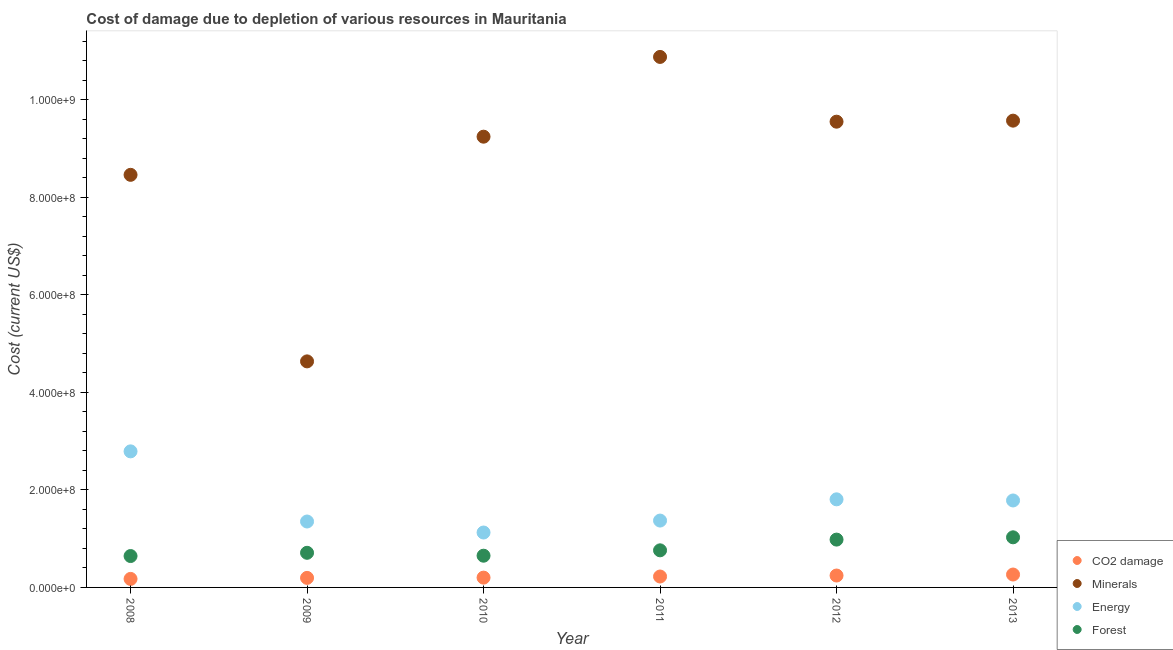How many different coloured dotlines are there?
Provide a succinct answer. 4. What is the cost of damage due to depletion of minerals in 2013?
Offer a terse response. 9.57e+08. Across all years, what is the maximum cost of damage due to depletion of energy?
Offer a terse response. 2.79e+08. Across all years, what is the minimum cost of damage due to depletion of coal?
Give a very brief answer. 1.75e+07. What is the total cost of damage due to depletion of coal in the graph?
Keep it short and to the point. 1.30e+08. What is the difference between the cost of damage due to depletion of minerals in 2009 and that in 2011?
Keep it short and to the point. -6.24e+08. What is the difference between the cost of damage due to depletion of minerals in 2012 and the cost of damage due to depletion of energy in 2009?
Provide a short and direct response. 8.20e+08. What is the average cost of damage due to depletion of energy per year?
Your answer should be compact. 1.71e+08. In the year 2008, what is the difference between the cost of damage due to depletion of energy and cost of damage due to depletion of forests?
Offer a terse response. 2.15e+08. What is the ratio of the cost of damage due to depletion of minerals in 2009 to that in 2011?
Your response must be concise. 0.43. Is the cost of damage due to depletion of minerals in 2010 less than that in 2011?
Keep it short and to the point. Yes. Is the difference between the cost of damage due to depletion of minerals in 2008 and 2010 greater than the difference between the cost of damage due to depletion of forests in 2008 and 2010?
Give a very brief answer. No. What is the difference between the highest and the second highest cost of damage due to depletion of forests?
Your answer should be compact. 4.69e+06. What is the difference between the highest and the lowest cost of damage due to depletion of energy?
Ensure brevity in your answer.  1.66e+08. Is it the case that in every year, the sum of the cost of damage due to depletion of forests and cost of damage due to depletion of coal is greater than the sum of cost of damage due to depletion of minerals and cost of damage due to depletion of energy?
Keep it short and to the point. No. Is it the case that in every year, the sum of the cost of damage due to depletion of coal and cost of damage due to depletion of minerals is greater than the cost of damage due to depletion of energy?
Your response must be concise. Yes. Does the cost of damage due to depletion of coal monotonically increase over the years?
Your response must be concise. Yes. Is the cost of damage due to depletion of coal strictly greater than the cost of damage due to depletion of minerals over the years?
Your response must be concise. No. Is the cost of damage due to depletion of energy strictly less than the cost of damage due to depletion of forests over the years?
Offer a terse response. No. How many dotlines are there?
Keep it short and to the point. 4. How many years are there in the graph?
Your answer should be very brief. 6. How many legend labels are there?
Make the answer very short. 4. How are the legend labels stacked?
Provide a short and direct response. Vertical. What is the title of the graph?
Ensure brevity in your answer.  Cost of damage due to depletion of various resources in Mauritania . What is the label or title of the X-axis?
Make the answer very short. Year. What is the label or title of the Y-axis?
Give a very brief answer. Cost (current US$). What is the Cost (current US$) of CO2 damage in 2008?
Make the answer very short. 1.75e+07. What is the Cost (current US$) of Minerals in 2008?
Keep it short and to the point. 8.46e+08. What is the Cost (current US$) in Energy in 2008?
Provide a short and direct response. 2.79e+08. What is the Cost (current US$) of Forest in 2008?
Offer a very short reply. 6.44e+07. What is the Cost (current US$) in CO2 damage in 2009?
Offer a very short reply. 1.96e+07. What is the Cost (current US$) in Minerals in 2009?
Ensure brevity in your answer.  4.64e+08. What is the Cost (current US$) in Energy in 2009?
Offer a terse response. 1.35e+08. What is the Cost (current US$) in Forest in 2009?
Provide a short and direct response. 7.10e+07. What is the Cost (current US$) in CO2 damage in 2010?
Make the answer very short. 2.01e+07. What is the Cost (current US$) of Minerals in 2010?
Your answer should be compact. 9.25e+08. What is the Cost (current US$) of Energy in 2010?
Offer a terse response. 1.13e+08. What is the Cost (current US$) in Forest in 2010?
Offer a terse response. 6.51e+07. What is the Cost (current US$) in CO2 damage in 2011?
Your answer should be very brief. 2.24e+07. What is the Cost (current US$) of Minerals in 2011?
Your response must be concise. 1.09e+09. What is the Cost (current US$) of Energy in 2011?
Make the answer very short. 1.37e+08. What is the Cost (current US$) of Forest in 2011?
Give a very brief answer. 7.61e+07. What is the Cost (current US$) in CO2 damage in 2012?
Your answer should be very brief. 2.44e+07. What is the Cost (current US$) of Minerals in 2012?
Your answer should be compact. 9.55e+08. What is the Cost (current US$) in Energy in 2012?
Give a very brief answer. 1.81e+08. What is the Cost (current US$) in Forest in 2012?
Your answer should be compact. 9.81e+07. What is the Cost (current US$) in CO2 damage in 2013?
Provide a succinct answer. 2.65e+07. What is the Cost (current US$) in Minerals in 2013?
Your answer should be compact. 9.57e+08. What is the Cost (current US$) of Energy in 2013?
Keep it short and to the point. 1.78e+08. What is the Cost (current US$) of Forest in 2013?
Your response must be concise. 1.03e+08. Across all years, what is the maximum Cost (current US$) in CO2 damage?
Offer a very short reply. 2.65e+07. Across all years, what is the maximum Cost (current US$) of Minerals?
Make the answer very short. 1.09e+09. Across all years, what is the maximum Cost (current US$) of Energy?
Your answer should be compact. 2.79e+08. Across all years, what is the maximum Cost (current US$) of Forest?
Offer a terse response. 1.03e+08. Across all years, what is the minimum Cost (current US$) of CO2 damage?
Provide a short and direct response. 1.75e+07. Across all years, what is the minimum Cost (current US$) in Minerals?
Your answer should be compact. 4.64e+08. Across all years, what is the minimum Cost (current US$) in Energy?
Give a very brief answer. 1.13e+08. Across all years, what is the minimum Cost (current US$) of Forest?
Keep it short and to the point. 6.44e+07. What is the total Cost (current US$) of CO2 damage in the graph?
Ensure brevity in your answer.  1.30e+08. What is the total Cost (current US$) in Minerals in the graph?
Your answer should be very brief. 5.24e+09. What is the total Cost (current US$) in Energy in the graph?
Make the answer very short. 1.02e+09. What is the total Cost (current US$) in Forest in the graph?
Your answer should be compact. 4.77e+08. What is the difference between the Cost (current US$) in CO2 damage in 2008 and that in 2009?
Offer a terse response. -2.10e+06. What is the difference between the Cost (current US$) in Minerals in 2008 and that in 2009?
Your response must be concise. 3.83e+08. What is the difference between the Cost (current US$) in Energy in 2008 and that in 2009?
Provide a short and direct response. 1.44e+08. What is the difference between the Cost (current US$) in Forest in 2008 and that in 2009?
Provide a short and direct response. -6.65e+06. What is the difference between the Cost (current US$) in CO2 damage in 2008 and that in 2010?
Your answer should be compact. -2.62e+06. What is the difference between the Cost (current US$) of Minerals in 2008 and that in 2010?
Make the answer very short. -7.82e+07. What is the difference between the Cost (current US$) in Energy in 2008 and that in 2010?
Provide a short and direct response. 1.66e+08. What is the difference between the Cost (current US$) in Forest in 2008 and that in 2010?
Keep it short and to the point. -6.86e+05. What is the difference between the Cost (current US$) of CO2 damage in 2008 and that in 2011?
Your response must be concise. -4.92e+06. What is the difference between the Cost (current US$) in Minerals in 2008 and that in 2011?
Your response must be concise. -2.42e+08. What is the difference between the Cost (current US$) of Energy in 2008 and that in 2011?
Make the answer very short. 1.42e+08. What is the difference between the Cost (current US$) in Forest in 2008 and that in 2011?
Provide a succinct answer. -1.17e+07. What is the difference between the Cost (current US$) in CO2 damage in 2008 and that in 2012?
Give a very brief answer. -6.94e+06. What is the difference between the Cost (current US$) in Minerals in 2008 and that in 2012?
Give a very brief answer. -1.09e+08. What is the difference between the Cost (current US$) of Energy in 2008 and that in 2012?
Make the answer very short. 9.84e+07. What is the difference between the Cost (current US$) of Forest in 2008 and that in 2012?
Your answer should be very brief. -3.37e+07. What is the difference between the Cost (current US$) of CO2 damage in 2008 and that in 2013?
Keep it short and to the point. -8.98e+06. What is the difference between the Cost (current US$) of Minerals in 2008 and that in 2013?
Provide a succinct answer. -1.11e+08. What is the difference between the Cost (current US$) of Energy in 2008 and that in 2013?
Offer a very short reply. 1.01e+08. What is the difference between the Cost (current US$) of Forest in 2008 and that in 2013?
Your answer should be compact. -3.84e+07. What is the difference between the Cost (current US$) in CO2 damage in 2009 and that in 2010?
Your answer should be compact. -5.16e+05. What is the difference between the Cost (current US$) of Minerals in 2009 and that in 2010?
Your response must be concise. -4.61e+08. What is the difference between the Cost (current US$) in Energy in 2009 and that in 2010?
Offer a very short reply. 2.26e+07. What is the difference between the Cost (current US$) of Forest in 2009 and that in 2010?
Give a very brief answer. 5.96e+06. What is the difference between the Cost (current US$) of CO2 damage in 2009 and that in 2011?
Provide a short and direct response. -2.82e+06. What is the difference between the Cost (current US$) of Minerals in 2009 and that in 2011?
Make the answer very short. -6.24e+08. What is the difference between the Cost (current US$) of Energy in 2009 and that in 2011?
Offer a very short reply. -1.92e+06. What is the difference between the Cost (current US$) in Forest in 2009 and that in 2011?
Ensure brevity in your answer.  -5.06e+06. What is the difference between the Cost (current US$) in CO2 damage in 2009 and that in 2012?
Offer a terse response. -4.83e+06. What is the difference between the Cost (current US$) of Minerals in 2009 and that in 2012?
Your response must be concise. -4.92e+08. What is the difference between the Cost (current US$) in Energy in 2009 and that in 2012?
Your answer should be compact. -4.55e+07. What is the difference between the Cost (current US$) in Forest in 2009 and that in 2012?
Keep it short and to the point. -2.71e+07. What is the difference between the Cost (current US$) in CO2 damage in 2009 and that in 2013?
Provide a short and direct response. -6.88e+06. What is the difference between the Cost (current US$) of Minerals in 2009 and that in 2013?
Your answer should be compact. -4.94e+08. What is the difference between the Cost (current US$) of Energy in 2009 and that in 2013?
Your answer should be very brief. -4.32e+07. What is the difference between the Cost (current US$) of Forest in 2009 and that in 2013?
Make the answer very short. -3.18e+07. What is the difference between the Cost (current US$) in CO2 damage in 2010 and that in 2011?
Offer a terse response. -2.30e+06. What is the difference between the Cost (current US$) in Minerals in 2010 and that in 2011?
Provide a succinct answer. -1.64e+08. What is the difference between the Cost (current US$) of Energy in 2010 and that in 2011?
Offer a terse response. -2.45e+07. What is the difference between the Cost (current US$) of Forest in 2010 and that in 2011?
Ensure brevity in your answer.  -1.10e+07. What is the difference between the Cost (current US$) of CO2 damage in 2010 and that in 2012?
Make the answer very short. -4.32e+06. What is the difference between the Cost (current US$) of Minerals in 2010 and that in 2012?
Your answer should be compact. -3.08e+07. What is the difference between the Cost (current US$) in Energy in 2010 and that in 2012?
Provide a short and direct response. -6.81e+07. What is the difference between the Cost (current US$) of Forest in 2010 and that in 2012?
Your answer should be compact. -3.30e+07. What is the difference between the Cost (current US$) of CO2 damage in 2010 and that in 2013?
Provide a succinct answer. -6.36e+06. What is the difference between the Cost (current US$) in Minerals in 2010 and that in 2013?
Keep it short and to the point. -3.29e+07. What is the difference between the Cost (current US$) in Energy in 2010 and that in 2013?
Your answer should be very brief. -6.57e+07. What is the difference between the Cost (current US$) in Forest in 2010 and that in 2013?
Your answer should be very brief. -3.77e+07. What is the difference between the Cost (current US$) in CO2 damage in 2011 and that in 2012?
Your response must be concise. -2.02e+06. What is the difference between the Cost (current US$) in Minerals in 2011 and that in 2012?
Keep it short and to the point. 1.33e+08. What is the difference between the Cost (current US$) of Energy in 2011 and that in 2012?
Make the answer very short. -4.36e+07. What is the difference between the Cost (current US$) in Forest in 2011 and that in 2012?
Provide a succinct answer. -2.20e+07. What is the difference between the Cost (current US$) in CO2 damage in 2011 and that in 2013?
Your answer should be compact. -4.06e+06. What is the difference between the Cost (current US$) in Minerals in 2011 and that in 2013?
Provide a short and direct response. 1.31e+08. What is the difference between the Cost (current US$) in Energy in 2011 and that in 2013?
Offer a terse response. -4.12e+07. What is the difference between the Cost (current US$) of Forest in 2011 and that in 2013?
Provide a short and direct response. -2.67e+07. What is the difference between the Cost (current US$) of CO2 damage in 2012 and that in 2013?
Provide a succinct answer. -2.04e+06. What is the difference between the Cost (current US$) in Minerals in 2012 and that in 2013?
Keep it short and to the point. -2.13e+06. What is the difference between the Cost (current US$) in Energy in 2012 and that in 2013?
Your response must be concise. 2.34e+06. What is the difference between the Cost (current US$) in Forest in 2012 and that in 2013?
Your answer should be compact. -4.69e+06. What is the difference between the Cost (current US$) in CO2 damage in 2008 and the Cost (current US$) in Minerals in 2009?
Give a very brief answer. -4.46e+08. What is the difference between the Cost (current US$) in CO2 damage in 2008 and the Cost (current US$) in Energy in 2009?
Your answer should be very brief. -1.18e+08. What is the difference between the Cost (current US$) of CO2 damage in 2008 and the Cost (current US$) of Forest in 2009?
Give a very brief answer. -5.36e+07. What is the difference between the Cost (current US$) in Minerals in 2008 and the Cost (current US$) in Energy in 2009?
Your answer should be compact. 7.11e+08. What is the difference between the Cost (current US$) of Minerals in 2008 and the Cost (current US$) of Forest in 2009?
Make the answer very short. 7.75e+08. What is the difference between the Cost (current US$) of Energy in 2008 and the Cost (current US$) of Forest in 2009?
Offer a terse response. 2.08e+08. What is the difference between the Cost (current US$) of CO2 damage in 2008 and the Cost (current US$) of Minerals in 2010?
Make the answer very short. -9.07e+08. What is the difference between the Cost (current US$) in CO2 damage in 2008 and the Cost (current US$) in Energy in 2010?
Your answer should be very brief. -9.52e+07. What is the difference between the Cost (current US$) of CO2 damage in 2008 and the Cost (current US$) of Forest in 2010?
Your answer should be very brief. -4.76e+07. What is the difference between the Cost (current US$) of Minerals in 2008 and the Cost (current US$) of Energy in 2010?
Your answer should be very brief. 7.34e+08. What is the difference between the Cost (current US$) in Minerals in 2008 and the Cost (current US$) in Forest in 2010?
Give a very brief answer. 7.81e+08. What is the difference between the Cost (current US$) in Energy in 2008 and the Cost (current US$) in Forest in 2010?
Make the answer very short. 2.14e+08. What is the difference between the Cost (current US$) of CO2 damage in 2008 and the Cost (current US$) of Minerals in 2011?
Offer a terse response. -1.07e+09. What is the difference between the Cost (current US$) of CO2 damage in 2008 and the Cost (current US$) of Energy in 2011?
Keep it short and to the point. -1.20e+08. What is the difference between the Cost (current US$) in CO2 damage in 2008 and the Cost (current US$) in Forest in 2011?
Provide a succinct answer. -5.86e+07. What is the difference between the Cost (current US$) in Minerals in 2008 and the Cost (current US$) in Energy in 2011?
Give a very brief answer. 7.09e+08. What is the difference between the Cost (current US$) in Minerals in 2008 and the Cost (current US$) in Forest in 2011?
Provide a short and direct response. 7.70e+08. What is the difference between the Cost (current US$) in Energy in 2008 and the Cost (current US$) in Forest in 2011?
Offer a very short reply. 2.03e+08. What is the difference between the Cost (current US$) in CO2 damage in 2008 and the Cost (current US$) in Minerals in 2012?
Your answer should be compact. -9.38e+08. What is the difference between the Cost (current US$) in CO2 damage in 2008 and the Cost (current US$) in Energy in 2012?
Your answer should be very brief. -1.63e+08. What is the difference between the Cost (current US$) in CO2 damage in 2008 and the Cost (current US$) in Forest in 2012?
Your answer should be compact. -8.06e+07. What is the difference between the Cost (current US$) in Minerals in 2008 and the Cost (current US$) in Energy in 2012?
Your answer should be compact. 6.66e+08. What is the difference between the Cost (current US$) in Minerals in 2008 and the Cost (current US$) in Forest in 2012?
Provide a short and direct response. 7.48e+08. What is the difference between the Cost (current US$) in Energy in 2008 and the Cost (current US$) in Forest in 2012?
Make the answer very short. 1.81e+08. What is the difference between the Cost (current US$) in CO2 damage in 2008 and the Cost (current US$) in Minerals in 2013?
Provide a succinct answer. -9.40e+08. What is the difference between the Cost (current US$) of CO2 damage in 2008 and the Cost (current US$) of Energy in 2013?
Offer a terse response. -1.61e+08. What is the difference between the Cost (current US$) of CO2 damage in 2008 and the Cost (current US$) of Forest in 2013?
Give a very brief answer. -8.53e+07. What is the difference between the Cost (current US$) of Minerals in 2008 and the Cost (current US$) of Energy in 2013?
Ensure brevity in your answer.  6.68e+08. What is the difference between the Cost (current US$) in Minerals in 2008 and the Cost (current US$) in Forest in 2013?
Your response must be concise. 7.44e+08. What is the difference between the Cost (current US$) in Energy in 2008 and the Cost (current US$) in Forest in 2013?
Ensure brevity in your answer.  1.76e+08. What is the difference between the Cost (current US$) of CO2 damage in 2009 and the Cost (current US$) of Minerals in 2010?
Offer a very short reply. -9.05e+08. What is the difference between the Cost (current US$) of CO2 damage in 2009 and the Cost (current US$) of Energy in 2010?
Your response must be concise. -9.31e+07. What is the difference between the Cost (current US$) in CO2 damage in 2009 and the Cost (current US$) in Forest in 2010?
Offer a very short reply. -4.55e+07. What is the difference between the Cost (current US$) in Minerals in 2009 and the Cost (current US$) in Energy in 2010?
Offer a very short reply. 3.51e+08. What is the difference between the Cost (current US$) of Minerals in 2009 and the Cost (current US$) of Forest in 2010?
Your answer should be very brief. 3.99e+08. What is the difference between the Cost (current US$) of Energy in 2009 and the Cost (current US$) of Forest in 2010?
Your response must be concise. 7.01e+07. What is the difference between the Cost (current US$) of CO2 damage in 2009 and the Cost (current US$) of Minerals in 2011?
Provide a short and direct response. -1.07e+09. What is the difference between the Cost (current US$) in CO2 damage in 2009 and the Cost (current US$) in Energy in 2011?
Provide a short and direct response. -1.18e+08. What is the difference between the Cost (current US$) in CO2 damage in 2009 and the Cost (current US$) in Forest in 2011?
Make the answer very short. -5.65e+07. What is the difference between the Cost (current US$) in Minerals in 2009 and the Cost (current US$) in Energy in 2011?
Make the answer very short. 3.27e+08. What is the difference between the Cost (current US$) in Minerals in 2009 and the Cost (current US$) in Forest in 2011?
Your response must be concise. 3.88e+08. What is the difference between the Cost (current US$) in Energy in 2009 and the Cost (current US$) in Forest in 2011?
Make the answer very short. 5.91e+07. What is the difference between the Cost (current US$) in CO2 damage in 2009 and the Cost (current US$) in Minerals in 2012?
Ensure brevity in your answer.  -9.36e+08. What is the difference between the Cost (current US$) of CO2 damage in 2009 and the Cost (current US$) of Energy in 2012?
Ensure brevity in your answer.  -1.61e+08. What is the difference between the Cost (current US$) in CO2 damage in 2009 and the Cost (current US$) in Forest in 2012?
Offer a terse response. -7.85e+07. What is the difference between the Cost (current US$) in Minerals in 2009 and the Cost (current US$) in Energy in 2012?
Provide a succinct answer. 2.83e+08. What is the difference between the Cost (current US$) of Minerals in 2009 and the Cost (current US$) of Forest in 2012?
Your response must be concise. 3.66e+08. What is the difference between the Cost (current US$) of Energy in 2009 and the Cost (current US$) of Forest in 2012?
Provide a succinct answer. 3.71e+07. What is the difference between the Cost (current US$) in CO2 damage in 2009 and the Cost (current US$) in Minerals in 2013?
Your answer should be very brief. -9.38e+08. What is the difference between the Cost (current US$) of CO2 damage in 2009 and the Cost (current US$) of Energy in 2013?
Offer a very short reply. -1.59e+08. What is the difference between the Cost (current US$) of CO2 damage in 2009 and the Cost (current US$) of Forest in 2013?
Your answer should be very brief. -8.32e+07. What is the difference between the Cost (current US$) of Minerals in 2009 and the Cost (current US$) of Energy in 2013?
Offer a terse response. 2.85e+08. What is the difference between the Cost (current US$) of Minerals in 2009 and the Cost (current US$) of Forest in 2013?
Make the answer very short. 3.61e+08. What is the difference between the Cost (current US$) of Energy in 2009 and the Cost (current US$) of Forest in 2013?
Provide a succinct answer. 3.24e+07. What is the difference between the Cost (current US$) in CO2 damage in 2010 and the Cost (current US$) in Minerals in 2011?
Your response must be concise. -1.07e+09. What is the difference between the Cost (current US$) of CO2 damage in 2010 and the Cost (current US$) of Energy in 2011?
Make the answer very short. -1.17e+08. What is the difference between the Cost (current US$) in CO2 damage in 2010 and the Cost (current US$) in Forest in 2011?
Ensure brevity in your answer.  -5.60e+07. What is the difference between the Cost (current US$) in Minerals in 2010 and the Cost (current US$) in Energy in 2011?
Ensure brevity in your answer.  7.87e+08. What is the difference between the Cost (current US$) in Minerals in 2010 and the Cost (current US$) in Forest in 2011?
Provide a short and direct response. 8.48e+08. What is the difference between the Cost (current US$) of Energy in 2010 and the Cost (current US$) of Forest in 2011?
Ensure brevity in your answer.  3.65e+07. What is the difference between the Cost (current US$) in CO2 damage in 2010 and the Cost (current US$) in Minerals in 2012?
Give a very brief answer. -9.35e+08. What is the difference between the Cost (current US$) in CO2 damage in 2010 and the Cost (current US$) in Energy in 2012?
Offer a terse response. -1.61e+08. What is the difference between the Cost (current US$) of CO2 damage in 2010 and the Cost (current US$) of Forest in 2012?
Your answer should be very brief. -7.80e+07. What is the difference between the Cost (current US$) in Minerals in 2010 and the Cost (current US$) in Energy in 2012?
Your answer should be compact. 7.44e+08. What is the difference between the Cost (current US$) of Minerals in 2010 and the Cost (current US$) of Forest in 2012?
Provide a succinct answer. 8.26e+08. What is the difference between the Cost (current US$) in Energy in 2010 and the Cost (current US$) in Forest in 2012?
Your answer should be compact. 1.45e+07. What is the difference between the Cost (current US$) of CO2 damage in 2010 and the Cost (current US$) of Minerals in 2013?
Your answer should be very brief. -9.37e+08. What is the difference between the Cost (current US$) of CO2 damage in 2010 and the Cost (current US$) of Energy in 2013?
Provide a succinct answer. -1.58e+08. What is the difference between the Cost (current US$) of CO2 damage in 2010 and the Cost (current US$) of Forest in 2013?
Provide a succinct answer. -8.27e+07. What is the difference between the Cost (current US$) in Minerals in 2010 and the Cost (current US$) in Energy in 2013?
Your answer should be compact. 7.46e+08. What is the difference between the Cost (current US$) in Minerals in 2010 and the Cost (current US$) in Forest in 2013?
Offer a terse response. 8.22e+08. What is the difference between the Cost (current US$) of Energy in 2010 and the Cost (current US$) of Forest in 2013?
Offer a terse response. 9.83e+06. What is the difference between the Cost (current US$) in CO2 damage in 2011 and the Cost (current US$) in Minerals in 2012?
Your answer should be very brief. -9.33e+08. What is the difference between the Cost (current US$) in CO2 damage in 2011 and the Cost (current US$) in Energy in 2012?
Offer a terse response. -1.58e+08. What is the difference between the Cost (current US$) of CO2 damage in 2011 and the Cost (current US$) of Forest in 2012?
Your response must be concise. -7.57e+07. What is the difference between the Cost (current US$) of Minerals in 2011 and the Cost (current US$) of Energy in 2012?
Give a very brief answer. 9.07e+08. What is the difference between the Cost (current US$) in Minerals in 2011 and the Cost (current US$) in Forest in 2012?
Your answer should be compact. 9.90e+08. What is the difference between the Cost (current US$) of Energy in 2011 and the Cost (current US$) of Forest in 2012?
Provide a short and direct response. 3.90e+07. What is the difference between the Cost (current US$) in CO2 damage in 2011 and the Cost (current US$) in Minerals in 2013?
Your response must be concise. -9.35e+08. What is the difference between the Cost (current US$) in CO2 damage in 2011 and the Cost (current US$) in Energy in 2013?
Your answer should be compact. -1.56e+08. What is the difference between the Cost (current US$) in CO2 damage in 2011 and the Cost (current US$) in Forest in 2013?
Give a very brief answer. -8.04e+07. What is the difference between the Cost (current US$) of Minerals in 2011 and the Cost (current US$) of Energy in 2013?
Give a very brief answer. 9.10e+08. What is the difference between the Cost (current US$) in Minerals in 2011 and the Cost (current US$) in Forest in 2013?
Make the answer very short. 9.85e+08. What is the difference between the Cost (current US$) of Energy in 2011 and the Cost (current US$) of Forest in 2013?
Your answer should be compact. 3.43e+07. What is the difference between the Cost (current US$) of CO2 damage in 2012 and the Cost (current US$) of Minerals in 2013?
Your answer should be very brief. -9.33e+08. What is the difference between the Cost (current US$) in CO2 damage in 2012 and the Cost (current US$) in Energy in 2013?
Offer a terse response. -1.54e+08. What is the difference between the Cost (current US$) in CO2 damage in 2012 and the Cost (current US$) in Forest in 2013?
Provide a succinct answer. -7.84e+07. What is the difference between the Cost (current US$) in Minerals in 2012 and the Cost (current US$) in Energy in 2013?
Ensure brevity in your answer.  7.77e+08. What is the difference between the Cost (current US$) in Minerals in 2012 and the Cost (current US$) in Forest in 2013?
Your answer should be very brief. 8.53e+08. What is the difference between the Cost (current US$) of Energy in 2012 and the Cost (current US$) of Forest in 2013?
Keep it short and to the point. 7.79e+07. What is the average Cost (current US$) of CO2 damage per year?
Keep it short and to the point. 2.17e+07. What is the average Cost (current US$) of Minerals per year?
Keep it short and to the point. 8.73e+08. What is the average Cost (current US$) in Energy per year?
Give a very brief answer. 1.71e+08. What is the average Cost (current US$) in Forest per year?
Offer a terse response. 7.96e+07. In the year 2008, what is the difference between the Cost (current US$) in CO2 damage and Cost (current US$) in Minerals?
Keep it short and to the point. -8.29e+08. In the year 2008, what is the difference between the Cost (current US$) in CO2 damage and Cost (current US$) in Energy?
Your response must be concise. -2.62e+08. In the year 2008, what is the difference between the Cost (current US$) of CO2 damage and Cost (current US$) of Forest?
Make the answer very short. -4.69e+07. In the year 2008, what is the difference between the Cost (current US$) in Minerals and Cost (current US$) in Energy?
Give a very brief answer. 5.67e+08. In the year 2008, what is the difference between the Cost (current US$) of Minerals and Cost (current US$) of Forest?
Ensure brevity in your answer.  7.82e+08. In the year 2008, what is the difference between the Cost (current US$) of Energy and Cost (current US$) of Forest?
Your answer should be compact. 2.15e+08. In the year 2009, what is the difference between the Cost (current US$) of CO2 damage and Cost (current US$) of Minerals?
Your answer should be very brief. -4.44e+08. In the year 2009, what is the difference between the Cost (current US$) in CO2 damage and Cost (current US$) in Energy?
Your response must be concise. -1.16e+08. In the year 2009, what is the difference between the Cost (current US$) in CO2 damage and Cost (current US$) in Forest?
Give a very brief answer. -5.15e+07. In the year 2009, what is the difference between the Cost (current US$) of Minerals and Cost (current US$) of Energy?
Make the answer very short. 3.28e+08. In the year 2009, what is the difference between the Cost (current US$) of Minerals and Cost (current US$) of Forest?
Provide a short and direct response. 3.93e+08. In the year 2009, what is the difference between the Cost (current US$) of Energy and Cost (current US$) of Forest?
Provide a succinct answer. 6.42e+07. In the year 2010, what is the difference between the Cost (current US$) of CO2 damage and Cost (current US$) of Minerals?
Ensure brevity in your answer.  -9.04e+08. In the year 2010, what is the difference between the Cost (current US$) in CO2 damage and Cost (current US$) in Energy?
Make the answer very short. -9.25e+07. In the year 2010, what is the difference between the Cost (current US$) of CO2 damage and Cost (current US$) of Forest?
Give a very brief answer. -4.50e+07. In the year 2010, what is the difference between the Cost (current US$) in Minerals and Cost (current US$) in Energy?
Your answer should be very brief. 8.12e+08. In the year 2010, what is the difference between the Cost (current US$) in Minerals and Cost (current US$) in Forest?
Your answer should be compact. 8.59e+08. In the year 2010, what is the difference between the Cost (current US$) of Energy and Cost (current US$) of Forest?
Keep it short and to the point. 4.76e+07. In the year 2011, what is the difference between the Cost (current US$) in CO2 damage and Cost (current US$) in Minerals?
Provide a succinct answer. -1.07e+09. In the year 2011, what is the difference between the Cost (current US$) in CO2 damage and Cost (current US$) in Energy?
Provide a short and direct response. -1.15e+08. In the year 2011, what is the difference between the Cost (current US$) in CO2 damage and Cost (current US$) in Forest?
Offer a terse response. -5.37e+07. In the year 2011, what is the difference between the Cost (current US$) in Minerals and Cost (current US$) in Energy?
Your answer should be very brief. 9.51e+08. In the year 2011, what is the difference between the Cost (current US$) of Minerals and Cost (current US$) of Forest?
Your response must be concise. 1.01e+09. In the year 2011, what is the difference between the Cost (current US$) in Energy and Cost (current US$) in Forest?
Your answer should be very brief. 6.10e+07. In the year 2012, what is the difference between the Cost (current US$) of CO2 damage and Cost (current US$) of Minerals?
Your answer should be very brief. -9.31e+08. In the year 2012, what is the difference between the Cost (current US$) of CO2 damage and Cost (current US$) of Energy?
Your answer should be very brief. -1.56e+08. In the year 2012, what is the difference between the Cost (current US$) in CO2 damage and Cost (current US$) in Forest?
Offer a terse response. -7.37e+07. In the year 2012, what is the difference between the Cost (current US$) of Minerals and Cost (current US$) of Energy?
Provide a short and direct response. 7.75e+08. In the year 2012, what is the difference between the Cost (current US$) in Minerals and Cost (current US$) in Forest?
Your response must be concise. 8.57e+08. In the year 2012, what is the difference between the Cost (current US$) in Energy and Cost (current US$) in Forest?
Your answer should be very brief. 8.26e+07. In the year 2013, what is the difference between the Cost (current US$) in CO2 damage and Cost (current US$) in Minerals?
Ensure brevity in your answer.  -9.31e+08. In the year 2013, what is the difference between the Cost (current US$) in CO2 damage and Cost (current US$) in Energy?
Offer a terse response. -1.52e+08. In the year 2013, what is the difference between the Cost (current US$) in CO2 damage and Cost (current US$) in Forest?
Your answer should be compact. -7.63e+07. In the year 2013, what is the difference between the Cost (current US$) of Minerals and Cost (current US$) of Energy?
Offer a very short reply. 7.79e+08. In the year 2013, what is the difference between the Cost (current US$) in Minerals and Cost (current US$) in Forest?
Ensure brevity in your answer.  8.55e+08. In the year 2013, what is the difference between the Cost (current US$) in Energy and Cost (current US$) in Forest?
Keep it short and to the point. 7.56e+07. What is the ratio of the Cost (current US$) in CO2 damage in 2008 to that in 2009?
Offer a very short reply. 0.89. What is the ratio of the Cost (current US$) of Minerals in 2008 to that in 2009?
Your answer should be very brief. 1.83. What is the ratio of the Cost (current US$) of Energy in 2008 to that in 2009?
Provide a short and direct response. 2.06. What is the ratio of the Cost (current US$) in Forest in 2008 to that in 2009?
Your answer should be compact. 0.91. What is the ratio of the Cost (current US$) in CO2 damage in 2008 to that in 2010?
Make the answer very short. 0.87. What is the ratio of the Cost (current US$) of Minerals in 2008 to that in 2010?
Offer a very short reply. 0.92. What is the ratio of the Cost (current US$) of Energy in 2008 to that in 2010?
Offer a terse response. 2.48. What is the ratio of the Cost (current US$) in CO2 damage in 2008 to that in 2011?
Offer a very short reply. 0.78. What is the ratio of the Cost (current US$) in Minerals in 2008 to that in 2011?
Make the answer very short. 0.78. What is the ratio of the Cost (current US$) of Energy in 2008 to that in 2011?
Provide a short and direct response. 2.04. What is the ratio of the Cost (current US$) in Forest in 2008 to that in 2011?
Offer a terse response. 0.85. What is the ratio of the Cost (current US$) in CO2 damage in 2008 to that in 2012?
Make the answer very short. 0.72. What is the ratio of the Cost (current US$) of Minerals in 2008 to that in 2012?
Keep it short and to the point. 0.89. What is the ratio of the Cost (current US$) in Energy in 2008 to that in 2012?
Keep it short and to the point. 1.54. What is the ratio of the Cost (current US$) of Forest in 2008 to that in 2012?
Ensure brevity in your answer.  0.66. What is the ratio of the Cost (current US$) of CO2 damage in 2008 to that in 2013?
Make the answer very short. 0.66. What is the ratio of the Cost (current US$) in Minerals in 2008 to that in 2013?
Provide a succinct answer. 0.88. What is the ratio of the Cost (current US$) of Energy in 2008 to that in 2013?
Give a very brief answer. 1.56. What is the ratio of the Cost (current US$) in Forest in 2008 to that in 2013?
Your answer should be very brief. 0.63. What is the ratio of the Cost (current US$) in CO2 damage in 2009 to that in 2010?
Your answer should be very brief. 0.97. What is the ratio of the Cost (current US$) of Minerals in 2009 to that in 2010?
Your answer should be compact. 0.5. What is the ratio of the Cost (current US$) in Energy in 2009 to that in 2010?
Keep it short and to the point. 1.2. What is the ratio of the Cost (current US$) of Forest in 2009 to that in 2010?
Offer a very short reply. 1.09. What is the ratio of the Cost (current US$) of CO2 damage in 2009 to that in 2011?
Your answer should be compact. 0.87. What is the ratio of the Cost (current US$) in Minerals in 2009 to that in 2011?
Provide a succinct answer. 0.43. What is the ratio of the Cost (current US$) in Forest in 2009 to that in 2011?
Your response must be concise. 0.93. What is the ratio of the Cost (current US$) of CO2 damage in 2009 to that in 2012?
Your answer should be compact. 0.8. What is the ratio of the Cost (current US$) of Minerals in 2009 to that in 2012?
Your answer should be compact. 0.49. What is the ratio of the Cost (current US$) of Energy in 2009 to that in 2012?
Your response must be concise. 0.75. What is the ratio of the Cost (current US$) of Forest in 2009 to that in 2012?
Ensure brevity in your answer.  0.72. What is the ratio of the Cost (current US$) in CO2 damage in 2009 to that in 2013?
Your answer should be compact. 0.74. What is the ratio of the Cost (current US$) of Minerals in 2009 to that in 2013?
Ensure brevity in your answer.  0.48. What is the ratio of the Cost (current US$) in Energy in 2009 to that in 2013?
Make the answer very short. 0.76. What is the ratio of the Cost (current US$) in Forest in 2009 to that in 2013?
Your answer should be compact. 0.69. What is the ratio of the Cost (current US$) of CO2 damage in 2010 to that in 2011?
Give a very brief answer. 0.9. What is the ratio of the Cost (current US$) in Minerals in 2010 to that in 2011?
Offer a very short reply. 0.85. What is the ratio of the Cost (current US$) of Energy in 2010 to that in 2011?
Your answer should be compact. 0.82. What is the ratio of the Cost (current US$) of Forest in 2010 to that in 2011?
Give a very brief answer. 0.86. What is the ratio of the Cost (current US$) in CO2 damage in 2010 to that in 2012?
Your answer should be very brief. 0.82. What is the ratio of the Cost (current US$) of Minerals in 2010 to that in 2012?
Your response must be concise. 0.97. What is the ratio of the Cost (current US$) of Energy in 2010 to that in 2012?
Provide a succinct answer. 0.62. What is the ratio of the Cost (current US$) in Forest in 2010 to that in 2012?
Offer a terse response. 0.66. What is the ratio of the Cost (current US$) of CO2 damage in 2010 to that in 2013?
Provide a succinct answer. 0.76. What is the ratio of the Cost (current US$) of Minerals in 2010 to that in 2013?
Your answer should be very brief. 0.97. What is the ratio of the Cost (current US$) in Energy in 2010 to that in 2013?
Offer a terse response. 0.63. What is the ratio of the Cost (current US$) in Forest in 2010 to that in 2013?
Ensure brevity in your answer.  0.63. What is the ratio of the Cost (current US$) in CO2 damage in 2011 to that in 2012?
Provide a succinct answer. 0.92. What is the ratio of the Cost (current US$) in Minerals in 2011 to that in 2012?
Your answer should be very brief. 1.14. What is the ratio of the Cost (current US$) in Energy in 2011 to that in 2012?
Offer a very short reply. 0.76. What is the ratio of the Cost (current US$) in Forest in 2011 to that in 2012?
Your answer should be very brief. 0.78. What is the ratio of the Cost (current US$) of CO2 damage in 2011 to that in 2013?
Offer a terse response. 0.85. What is the ratio of the Cost (current US$) in Minerals in 2011 to that in 2013?
Ensure brevity in your answer.  1.14. What is the ratio of the Cost (current US$) in Energy in 2011 to that in 2013?
Make the answer very short. 0.77. What is the ratio of the Cost (current US$) of Forest in 2011 to that in 2013?
Provide a short and direct response. 0.74. What is the ratio of the Cost (current US$) of CO2 damage in 2012 to that in 2013?
Give a very brief answer. 0.92. What is the ratio of the Cost (current US$) in Energy in 2012 to that in 2013?
Offer a terse response. 1.01. What is the ratio of the Cost (current US$) of Forest in 2012 to that in 2013?
Your response must be concise. 0.95. What is the difference between the highest and the second highest Cost (current US$) in CO2 damage?
Offer a terse response. 2.04e+06. What is the difference between the highest and the second highest Cost (current US$) of Minerals?
Give a very brief answer. 1.31e+08. What is the difference between the highest and the second highest Cost (current US$) in Energy?
Give a very brief answer. 9.84e+07. What is the difference between the highest and the second highest Cost (current US$) of Forest?
Keep it short and to the point. 4.69e+06. What is the difference between the highest and the lowest Cost (current US$) of CO2 damage?
Offer a very short reply. 8.98e+06. What is the difference between the highest and the lowest Cost (current US$) in Minerals?
Offer a terse response. 6.24e+08. What is the difference between the highest and the lowest Cost (current US$) of Energy?
Your answer should be very brief. 1.66e+08. What is the difference between the highest and the lowest Cost (current US$) of Forest?
Ensure brevity in your answer.  3.84e+07. 